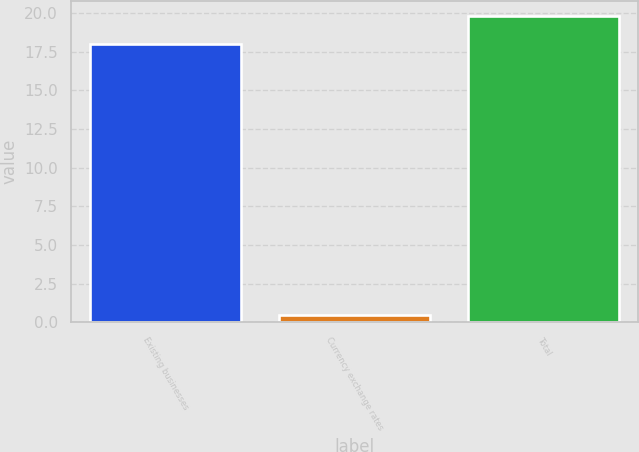Convert chart to OTSL. <chart><loc_0><loc_0><loc_500><loc_500><bar_chart><fcel>Existing businesses<fcel>Currency exchange rates<fcel>Total<nl><fcel>18<fcel>0.5<fcel>19.8<nl></chart> 